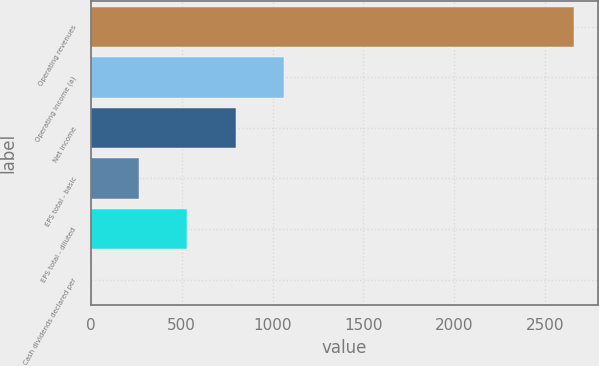Convert chart to OTSL. <chart><loc_0><loc_0><loc_500><loc_500><bar_chart><fcel>Operating revenues<fcel>Operating income (a)<fcel>Net income<fcel>EPS total - basic<fcel>EPS total - diluted<fcel>Cash dividends declared per<nl><fcel>2658<fcel>1063.42<fcel>797.66<fcel>266.14<fcel>531.9<fcel>0.38<nl></chart> 